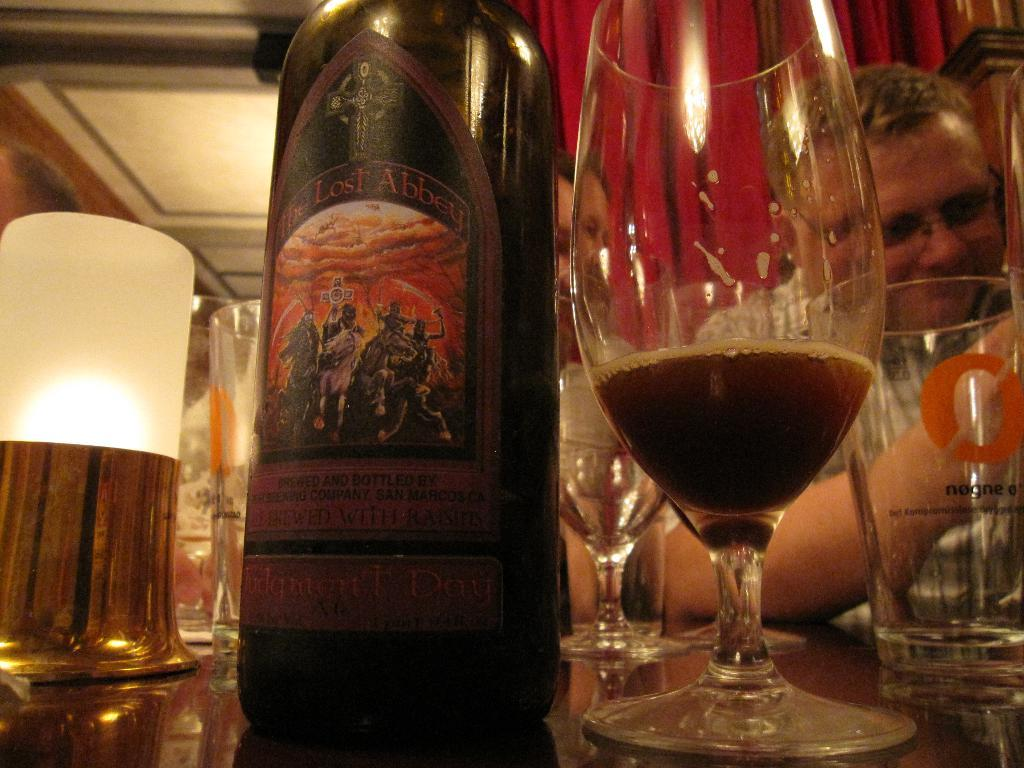What objects are on the table in the image? There are glasses and a wine bottle on the table in the image. What can be seen above the table? There is a light in the image. Who is present in the image? There is a person in front of the table. What is behind the person in the image? There are curtains behind the person. What type of guitar is the person playing in the image? There is no guitar present in the image; the person is not playing any instrument. 